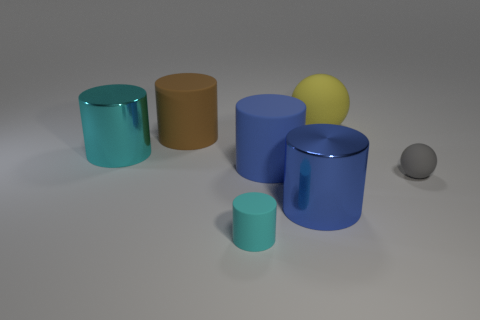Can you describe the material properties of the objects seen in the image? The objects in the image appear to have matte and shiny surfaces. The cylinders range from high-gloss finishes that reflect their surroundings to less reflective matte textures, suggesting variation in material like metal for the reflective ones and perhaps coated or unpolished metal or hard plastic for the matte surfaces. Are there any elements in this image that indicate a light source? Yes, the highlights and reflections on the surface of the shiny objects, particularly the cyan and gray cylinders, suggest a light source above and slightly to the side of the scene, providing a soft overhead illumination. 